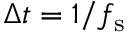<formula> <loc_0><loc_0><loc_500><loc_500>\Delta t = 1 / f _ { s }</formula> 